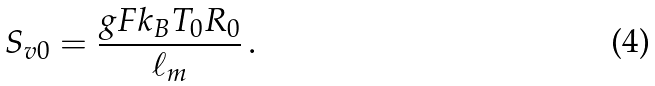<formula> <loc_0><loc_0><loc_500><loc_500>S _ { v 0 } = \frac { g F k _ { B } T _ { 0 } R _ { 0 } } { \ell _ { m } } \, .</formula> 